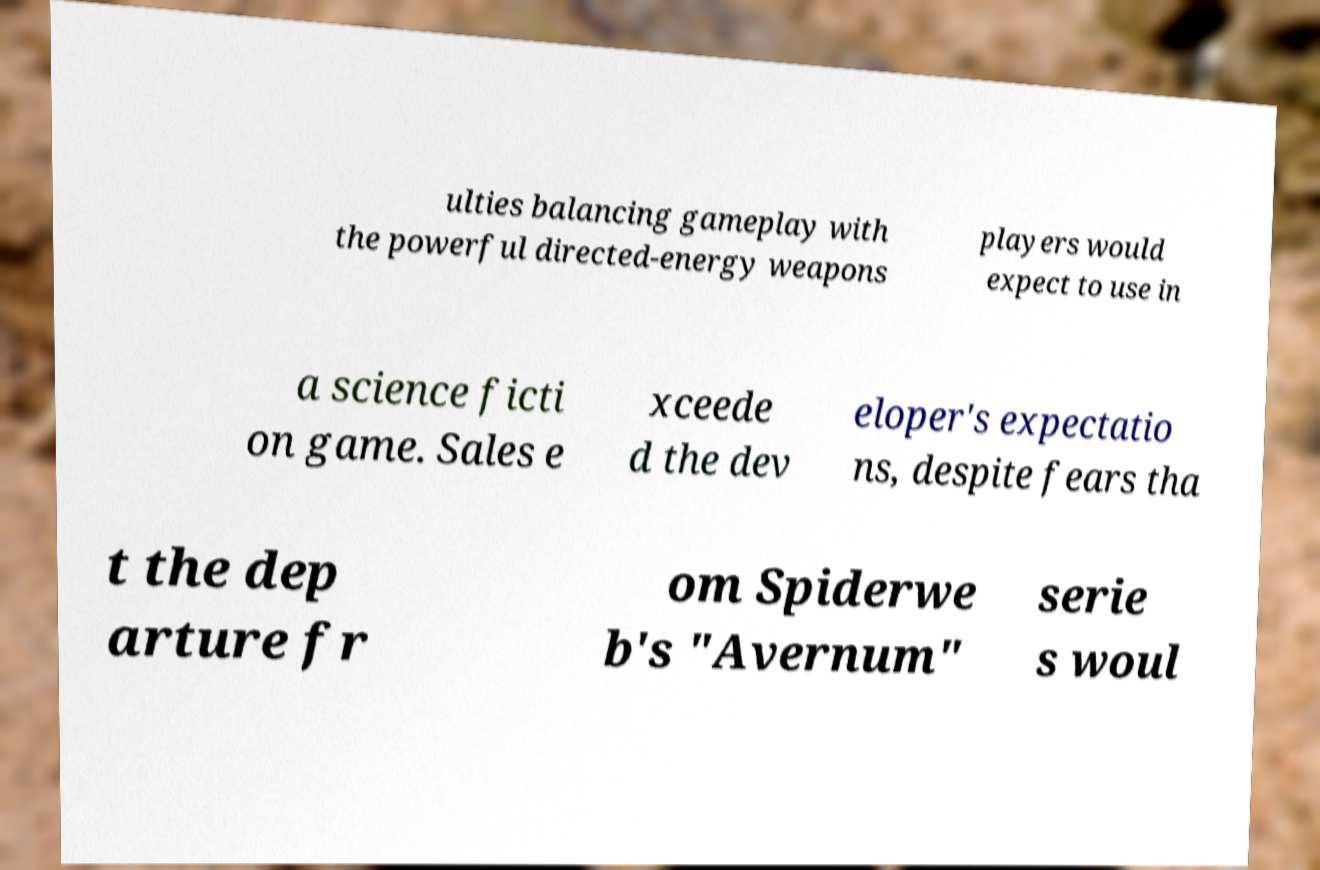Please read and relay the text visible in this image. What does it say? ulties balancing gameplay with the powerful directed-energy weapons players would expect to use in a science ficti on game. Sales e xceede d the dev eloper's expectatio ns, despite fears tha t the dep arture fr om Spiderwe b's "Avernum" serie s woul 